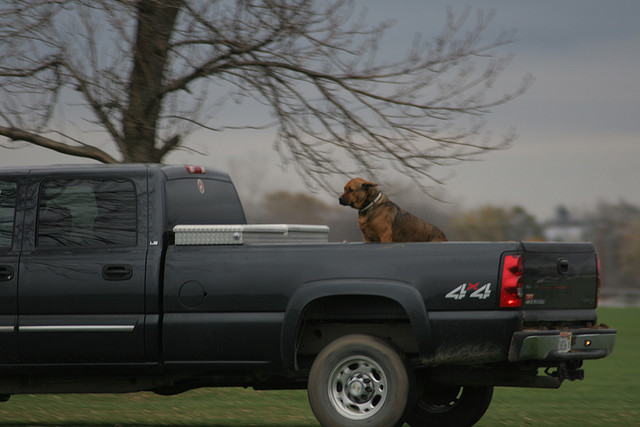<image>What type of car is next to the dogs? I am not sure about the type of car next to the dogs. It could be a truck or a Ford. What type of car is next to the dogs? I am not sure what type of car is next to the dogs. It can be seen as 'truck', 'truck dodge' or 'ford'. 